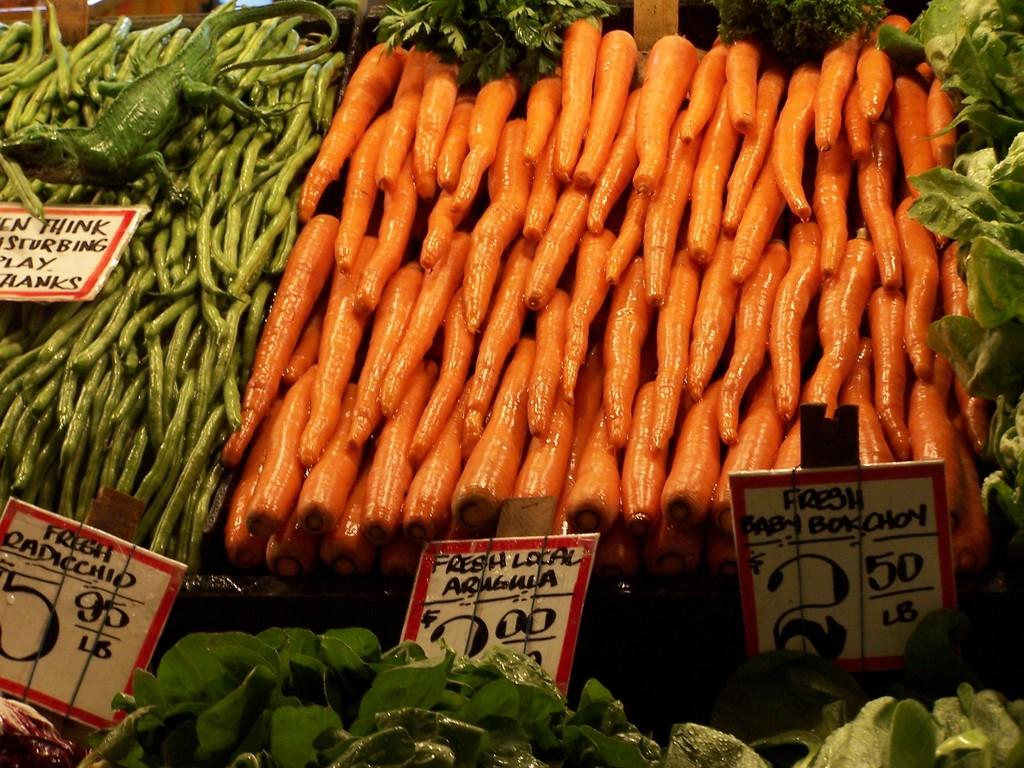What type of food items are present in the image? There are vegetables in the image. What else can be seen in the image besides the vegetables? There are boards with text in the image. How many tickets can be seen in the image? There are no tickets present in the image; it features vegetables and boards with text. 